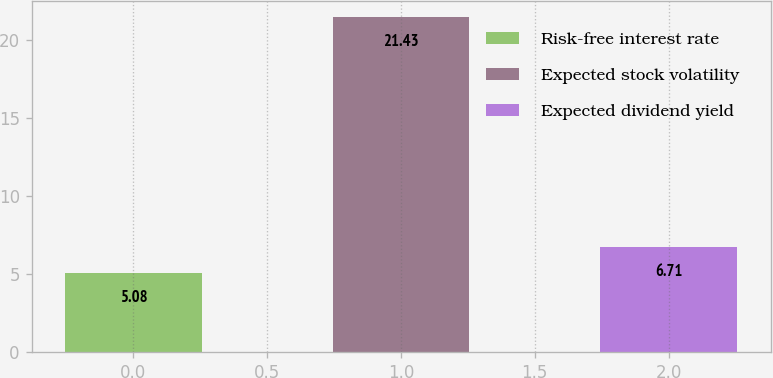<chart> <loc_0><loc_0><loc_500><loc_500><bar_chart><fcel>Risk-free interest rate<fcel>Expected stock volatility<fcel>Expected dividend yield<nl><fcel>5.08<fcel>21.43<fcel>6.71<nl></chart> 